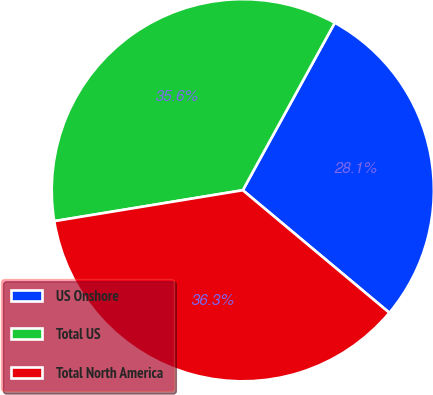Convert chart to OTSL. <chart><loc_0><loc_0><loc_500><loc_500><pie_chart><fcel>US Onshore<fcel>Total US<fcel>Total North America<nl><fcel>28.09%<fcel>35.58%<fcel>36.33%<nl></chart> 